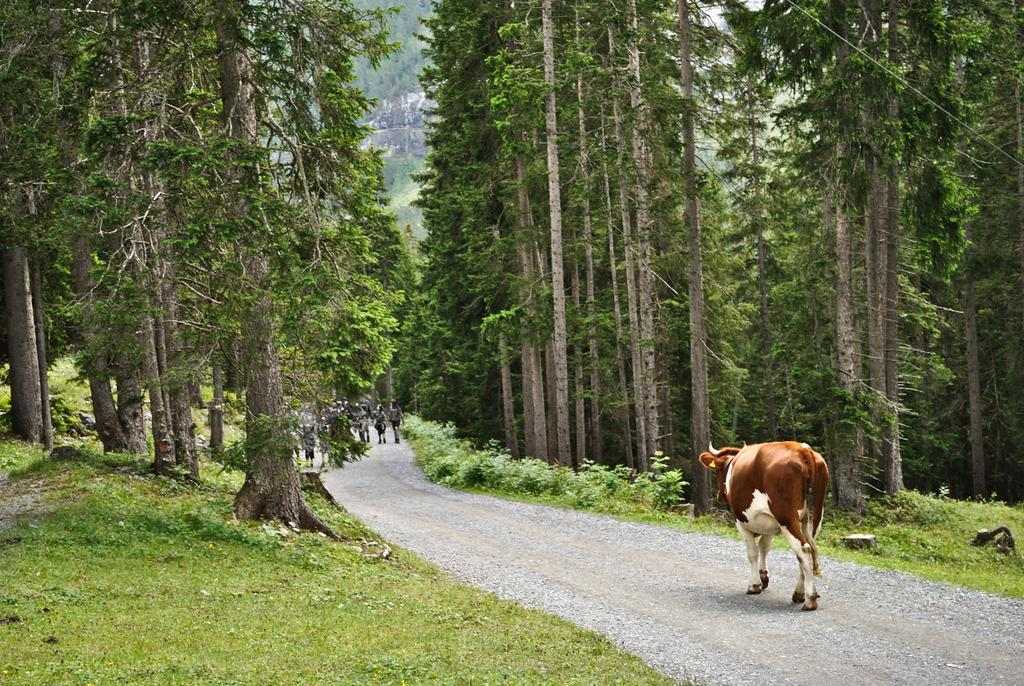What animal can be seen in the image? There is a cow in the image. What are the people in the image doing? The people in the image are walking on the road. What type of vegetation is present on either side of the road? Trees and grass are visible on either side of the road. Can you hear the cow laughing in the image? There is no sound in the image, and therefore we cannot hear the cow laughing. Additionally, cows do not laugh. 